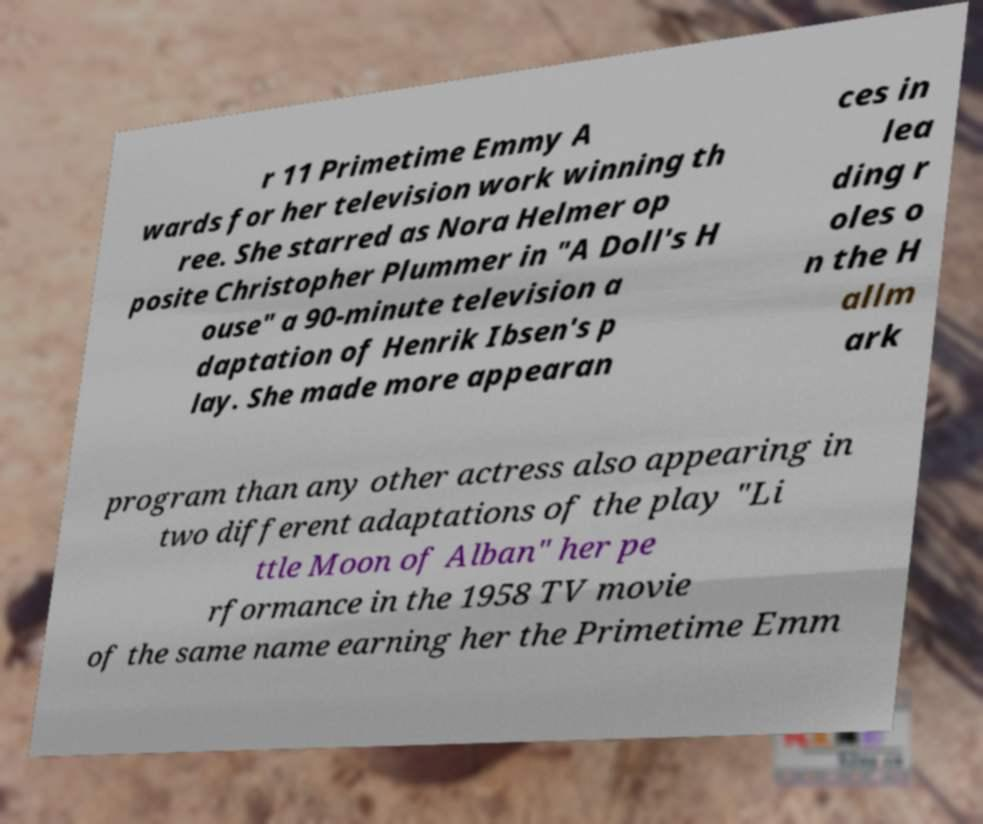There's text embedded in this image that I need extracted. Can you transcribe it verbatim? r 11 Primetime Emmy A wards for her television work winning th ree. She starred as Nora Helmer op posite Christopher Plummer in "A Doll's H ouse" a 90-minute television a daptation of Henrik Ibsen's p lay. She made more appearan ces in lea ding r oles o n the H allm ark program than any other actress also appearing in two different adaptations of the play "Li ttle Moon of Alban" her pe rformance in the 1958 TV movie of the same name earning her the Primetime Emm 